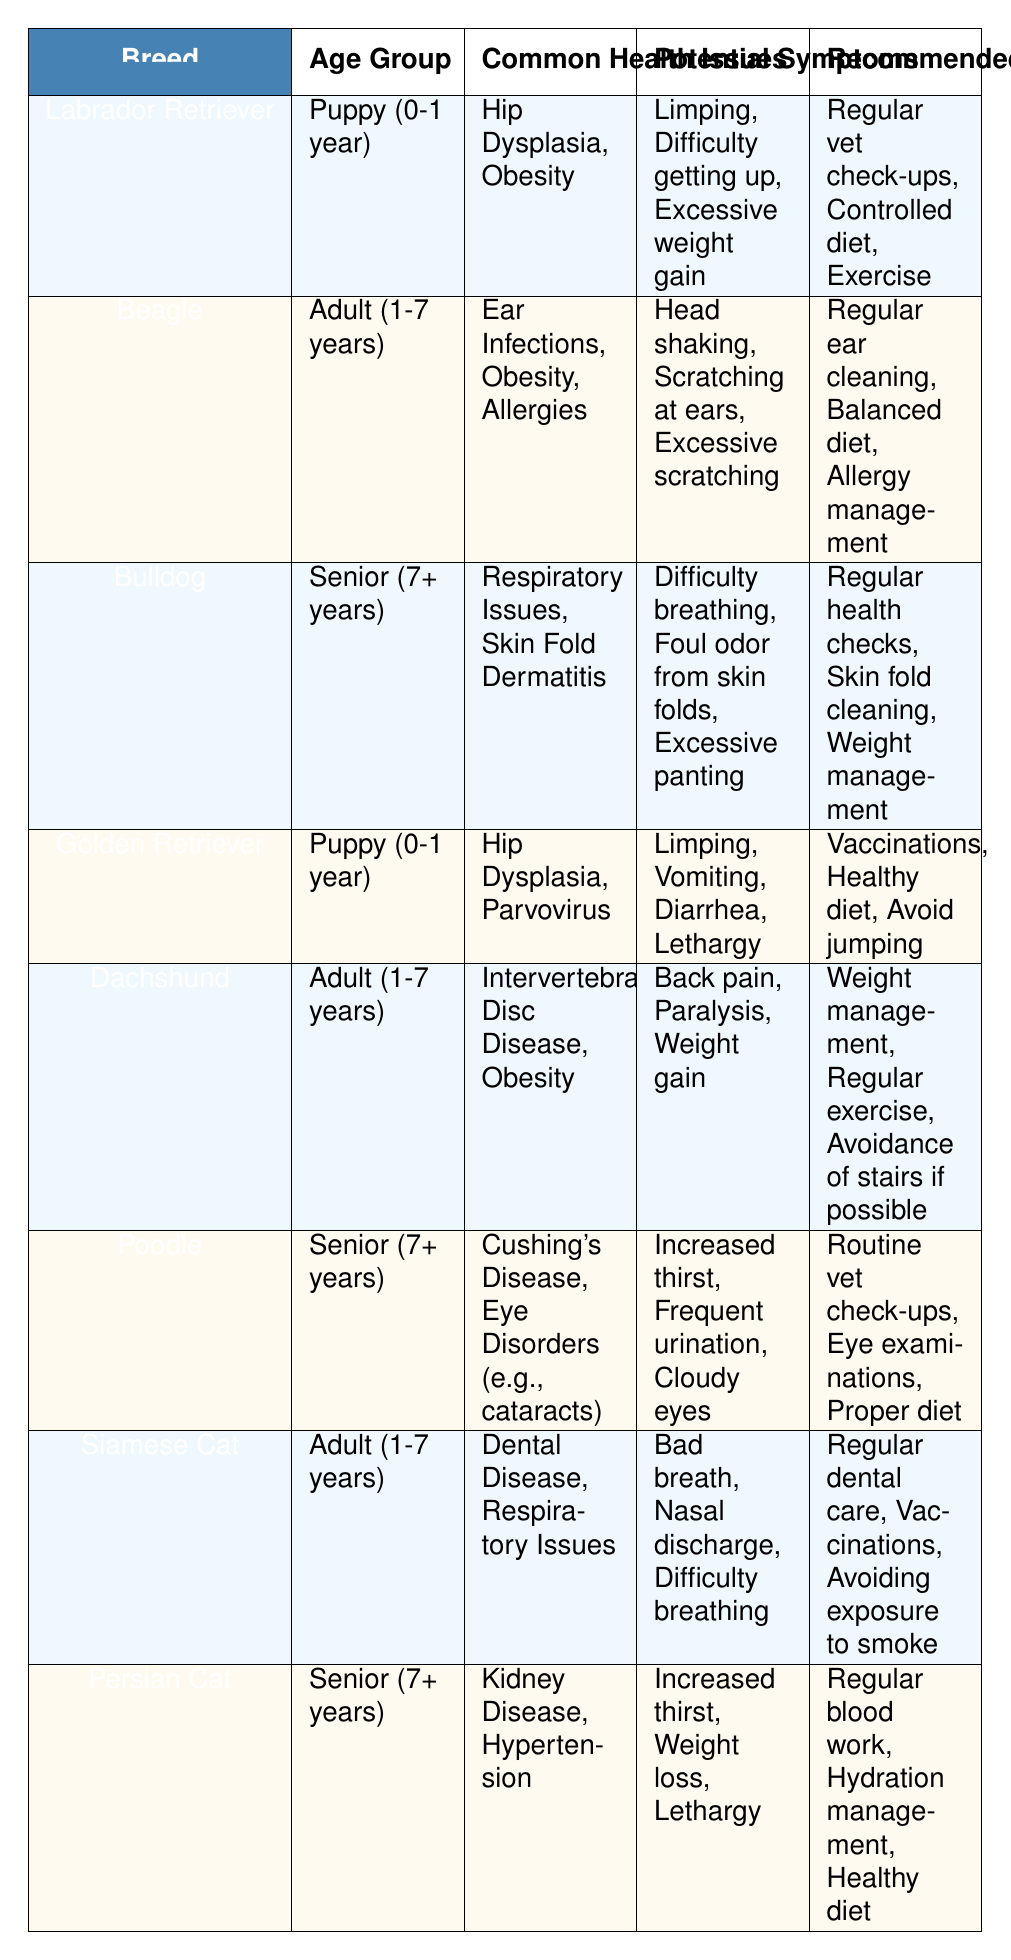What common health issues does the Labrador Retriever face as a puppy? The table lists the common health issues for the Labrador Retriever in the puppy age group (0-1 year), which are Hip Dysplasia and Obesity.
Answer: Hip Dysplasia, Obesity Which breed is associated with respiratory issues in seniors? By examining the data under the "Senior (7+ years)" age group, the Bulldog is indicated to have Respiratory Issues as a common health issue.
Answer: Bulldog How many common health issues does the Beagle have according to the table? The Beagle, in the Adult (1-7 years) category, has three common health issues listed: Ear Infections, Obesity, and Allergies.
Answer: Three True or False: The Poodle has a common health issue related to vision. The table states that the Poodle has Eye Disorders listed as a common health issue, which relates to vision problems; therefore, the statement is true.
Answer: True What are the potential symptoms of obesity for Dachshunds? The potential symptoms associated with obesity in Dachshunds include Back pain, Paralysis, and Weight gain, as stated in the relevant row of the table.
Answer: Back pain, Paralysis, Weight gain List the recommended preventive measures for a Golden Retriever. According to the table, the recommended preventive measures for a Golden Retriever as a puppy (0-1 year) include Vaccinations, Healthy diet, and Avoid jumping.
Answer: Vaccinations, Healthy diet, Avoid jumping If a Beagle has ear infections, what should be done to prevent further issues? The table recommends regular ear cleaning as a preventive measure for Beagles experiencing ear infections, along with a balanced diet and allergy management.
Answer: Regular ear cleaning What breed and age group experience intervertebral disc disease? The Dachshund in the Adult (1-7 years) age group is listed as experiencing Intervertebral Disc Disease according to the data in the table.
Answer: Dachshund, Adult (1-7 years) Which two breeds are listed with common health issues in senior age groups? The table indicates Bulldog and Persian Cat as the two breeds (Senior (7+ years)) with common health issues, which are Respiratory Issues and Kidney Disease, respectively.
Answer: Bulldog, Persian Cat How many total common health issues are listed in the table for senior pets? The table includes common health issues for two senior breeds: Bulldog (2 issues) and Persian Cat (2 issues), totaling 4 health issues for senior pets.
Answer: Four 